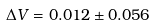Convert formula to latex. <formula><loc_0><loc_0><loc_500><loc_500>\Delta V = 0 . 0 1 2 \pm 0 . 0 5 6</formula> 